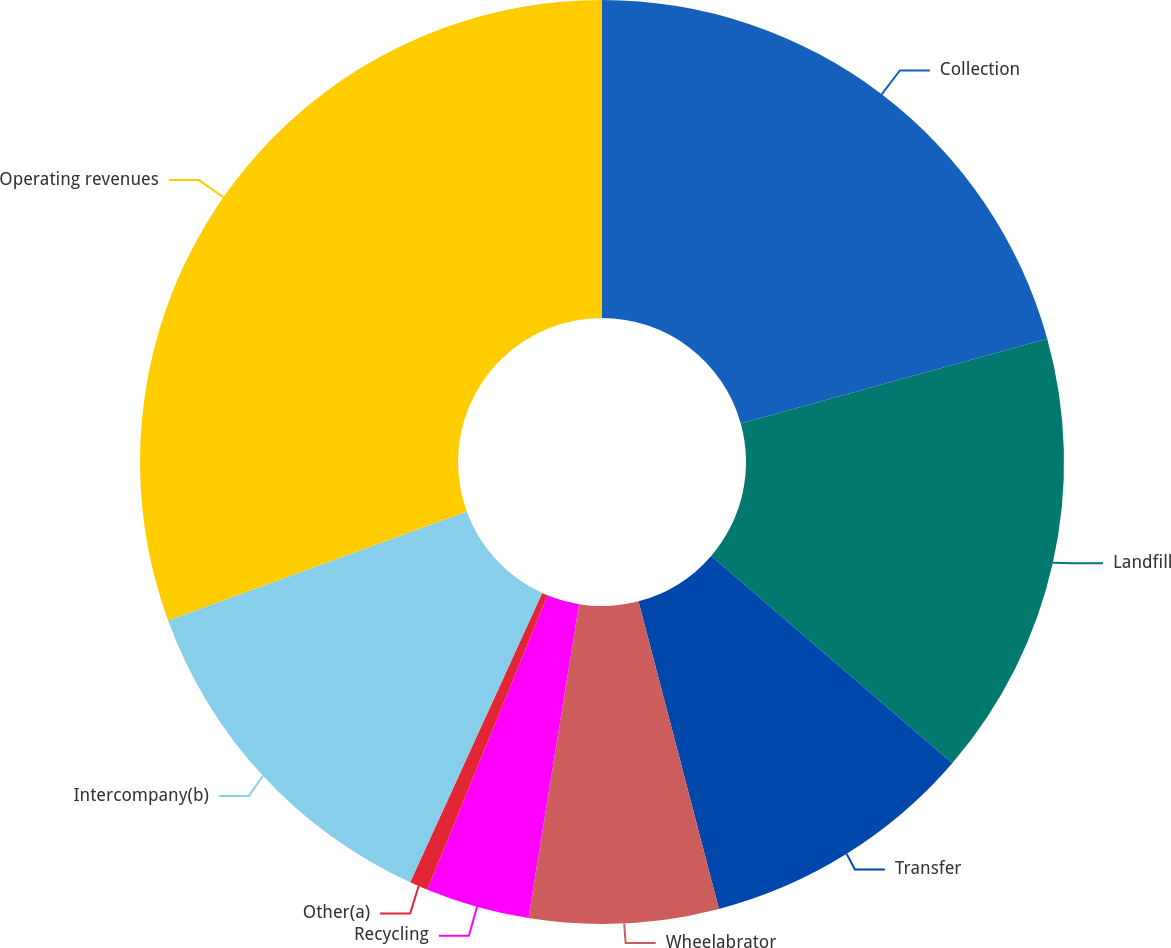Convert chart to OTSL. <chart><loc_0><loc_0><loc_500><loc_500><pie_chart><fcel>Collection<fcel>Landfill<fcel>Transfer<fcel>Wheelabrator<fcel>Recycling<fcel>Other(a)<fcel>Intercompany(b)<fcel>Operating revenues<nl><fcel>20.7%<fcel>15.61%<fcel>9.62%<fcel>6.62%<fcel>3.63%<fcel>0.64%<fcel>12.61%<fcel>30.58%<nl></chart> 